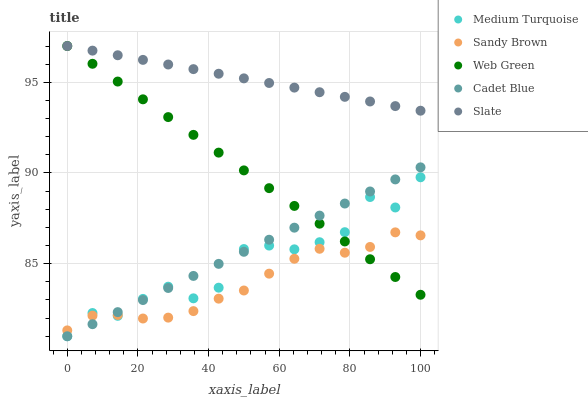Does Sandy Brown have the minimum area under the curve?
Answer yes or no. Yes. Does Slate have the maximum area under the curve?
Answer yes or no. Yes. Does Cadet Blue have the minimum area under the curve?
Answer yes or no. No. Does Cadet Blue have the maximum area under the curve?
Answer yes or no. No. Is Slate the smoothest?
Answer yes or no. Yes. Is Medium Turquoise the roughest?
Answer yes or no. Yes. Is Cadet Blue the smoothest?
Answer yes or no. No. Is Cadet Blue the roughest?
Answer yes or no. No. Does Cadet Blue have the lowest value?
Answer yes or no. Yes. Does Sandy Brown have the lowest value?
Answer yes or no. No. Does Web Green have the highest value?
Answer yes or no. Yes. Does Cadet Blue have the highest value?
Answer yes or no. No. Is Sandy Brown less than Slate?
Answer yes or no. Yes. Is Slate greater than Cadet Blue?
Answer yes or no. Yes. Does Web Green intersect Medium Turquoise?
Answer yes or no. Yes. Is Web Green less than Medium Turquoise?
Answer yes or no. No. Is Web Green greater than Medium Turquoise?
Answer yes or no. No. Does Sandy Brown intersect Slate?
Answer yes or no. No. 